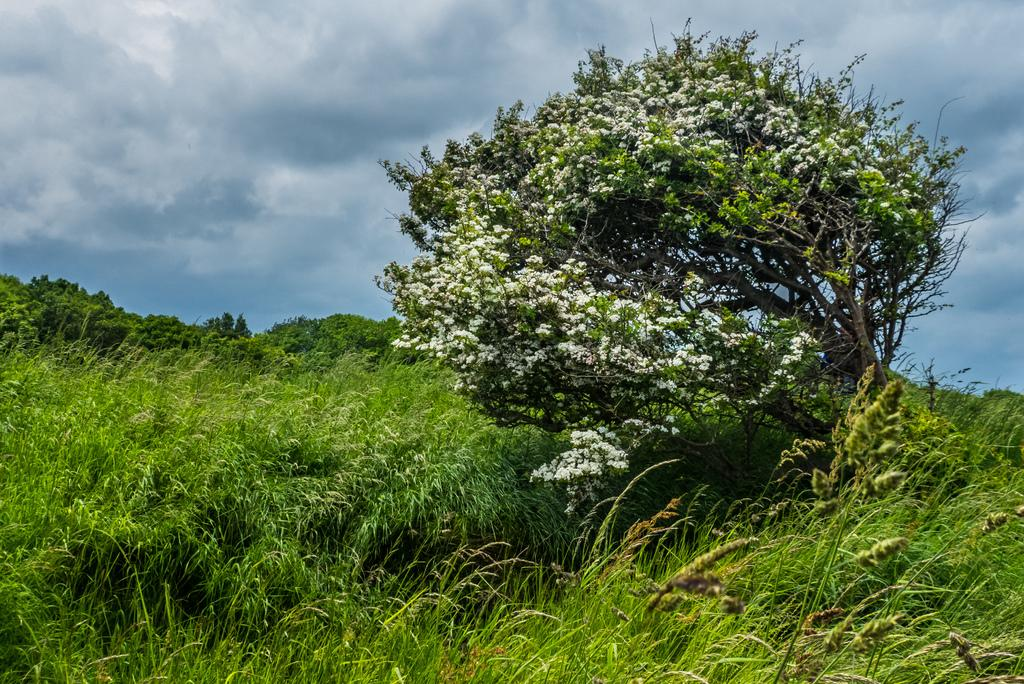What type of vegetation can be seen in the image? There is grass in the image. Are there any other plants visible in the image? Yes, there are trees and flowers in the image. What can be seen in the background of the image? The sky is visible in the background of the image. What is the condition of the sky in the image? Clouds are present in the sky. Can you tell me how many babies are playing with the horse in the image? There are no babies or horses present in the image. What type of war is depicted in the image? There is no depiction of war in the image; it features grass, trees, flowers, and a sky with clouds. 